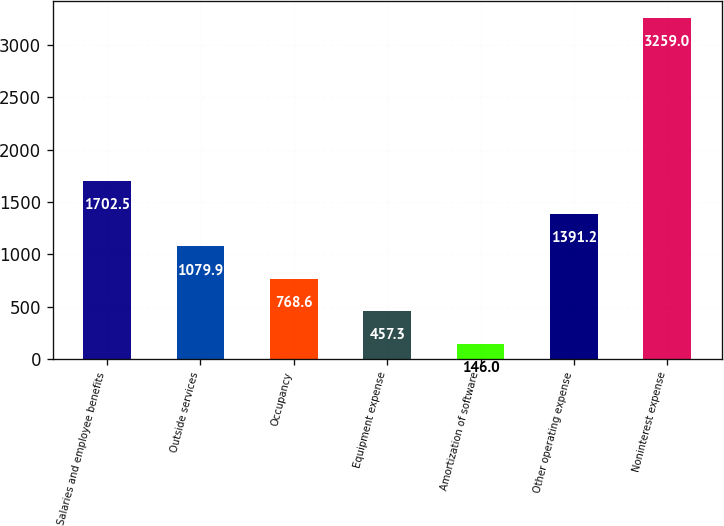<chart> <loc_0><loc_0><loc_500><loc_500><bar_chart><fcel>Salaries and employee benefits<fcel>Outside services<fcel>Occupancy<fcel>Equipment expense<fcel>Amortization of software<fcel>Other operating expense<fcel>Noninterest expense<nl><fcel>1702.5<fcel>1079.9<fcel>768.6<fcel>457.3<fcel>146<fcel>1391.2<fcel>3259<nl></chart> 